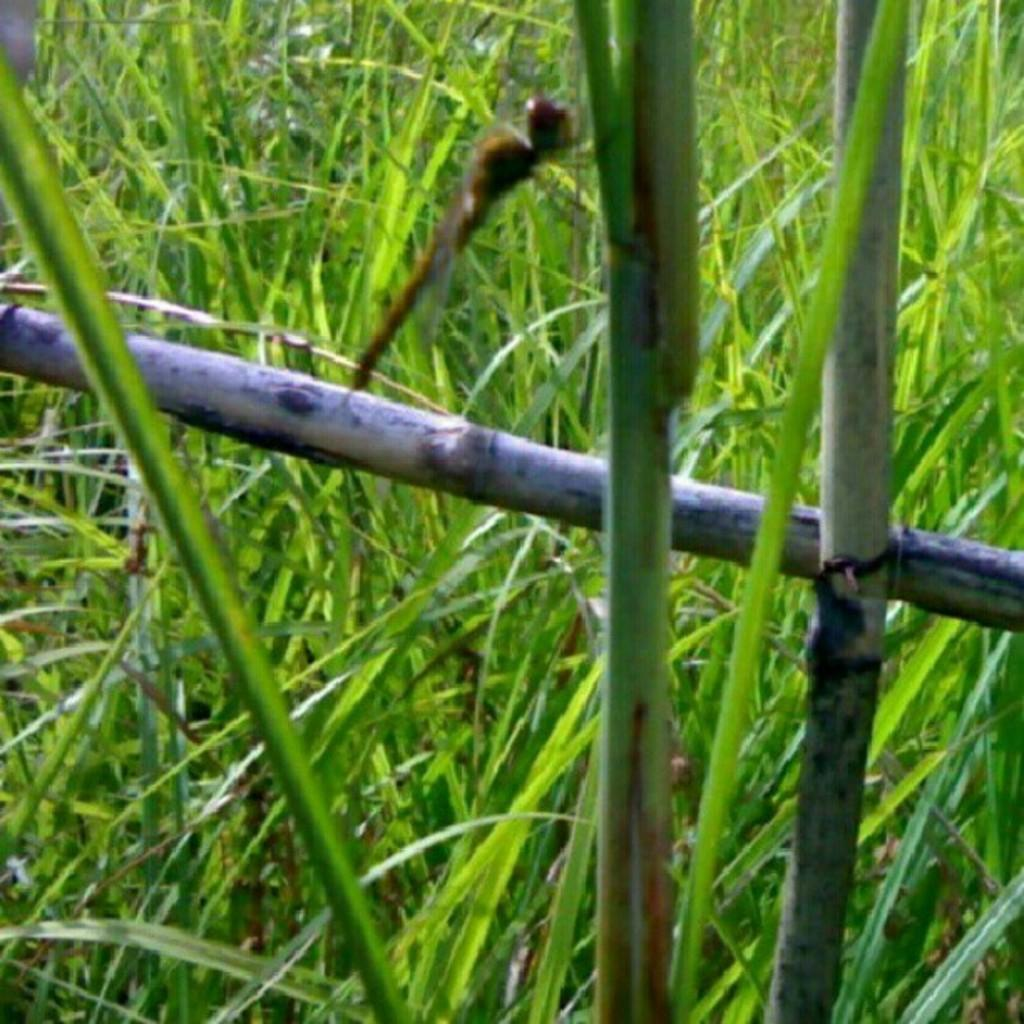What type of vegetation is present in the center of the image? There is grass in the center of the image. What else can be seen in the center of the image besides the grass? There are sticks and a few other objects in the center of the image. What is your daughter doing in the image? There is no mention of a daughter or any person in the image, so this question cannot be answered. 